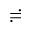Convert formula to latex. <formula><loc_0><loc_0><loc_500><loc_500>\risingdotseq</formula> 